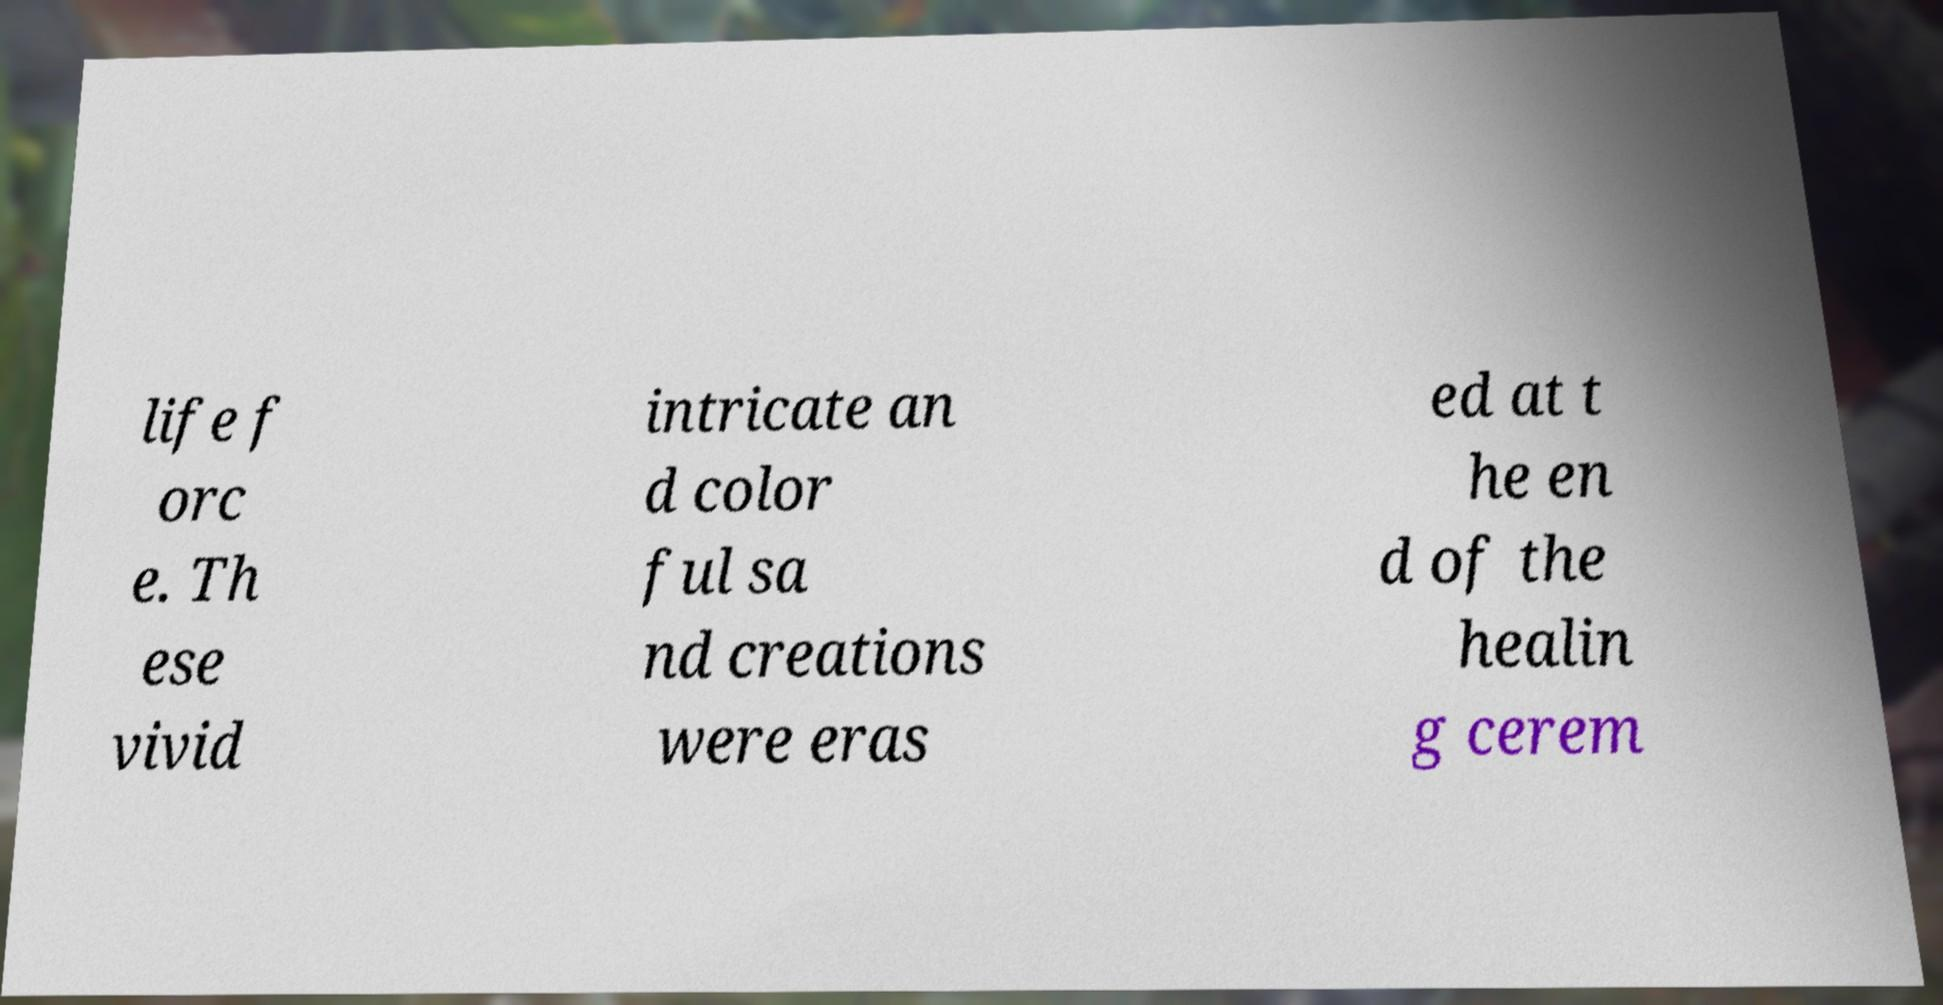What messages or text are displayed in this image? I need them in a readable, typed format. life f orc e. Th ese vivid intricate an d color ful sa nd creations were eras ed at t he en d of the healin g cerem 